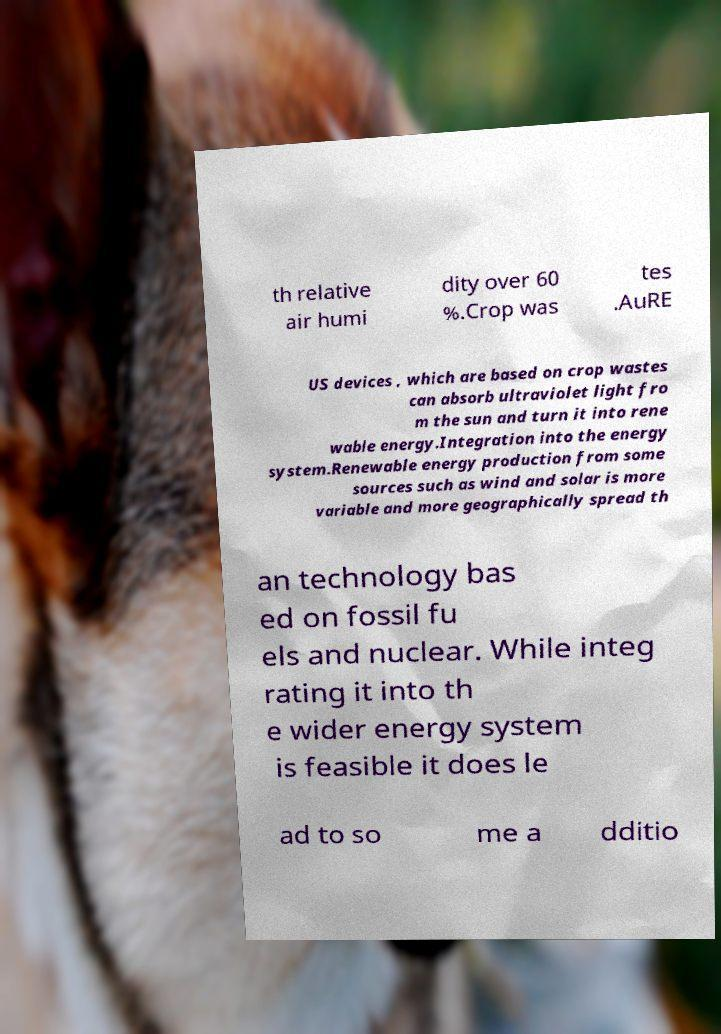What messages or text are displayed in this image? I need them in a readable, typed format. th relative air humi dity over 60 %.Crop was tes .AuRE US devices , which are based on crop wastes can absorb ultraviolet light fro m the sun and turn it into rene wable energy.Integration into the energy system.Renewable energy production from some sources such as wind and solar is more variable and more geographically spread th an technology bas ed on fossil fu els and nuclear. While integ rating it into th e wider energy system is feasible it does le ad to so me a dditio 